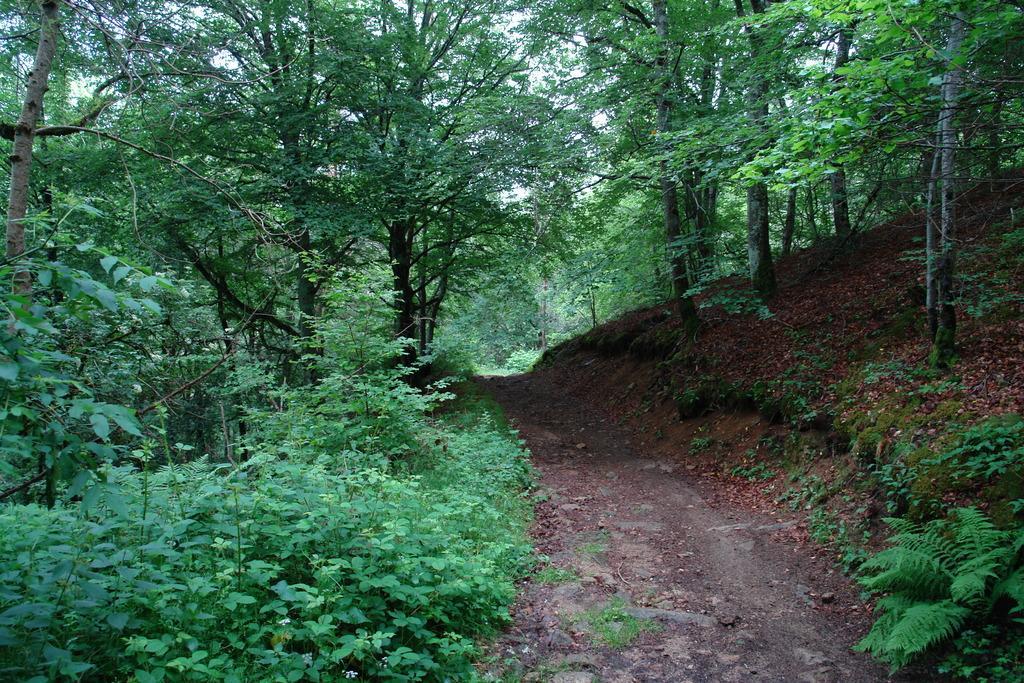How would you summarize this image in a sentence or two? In this picture I can see there is a mountain on the right side and there are trees and onto left side there is grass, there are plants and trees. 